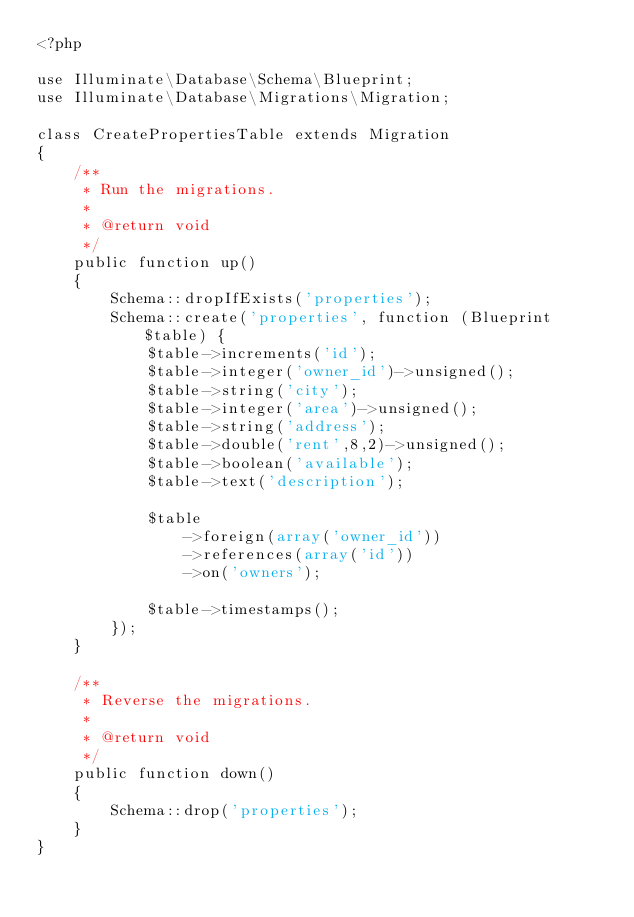<code> <loc_0><loc_0><loc_500><loc_500><_PHP_><?php

use Illuminate\Database\Schema\Blueprint;
use Illuminate\Database\Migrations\Migration;

class CreatePropertiesTable extends Migration
{
    /**
     * Run the migrations.
     *
     * @return void
     */
    public function up()
    {
        Schema::dropIfExists('properties');
        Schema::create('properties', function (Blueprint $table) {
            $table->increments('id');
            $table->integer('owner_id')->unsigned();
            $table->string('city');
            $table->integer('area')->unsigned();
            $table->string('address');
            $table->double('rent',8,2)->unsigned();
            $table->boolean('available');
            $table->text('description');

            $table
                ->foreign(array('owner_id'))
                ->references(array('id'))
                ->on('owners');

            $table->timestamps();
        });
    }

    /**
     * Reverse the migrations.
     *
     * @return void
     */
    public function down()
    {
        Schema::drop('properties');
    }
}
</code> 